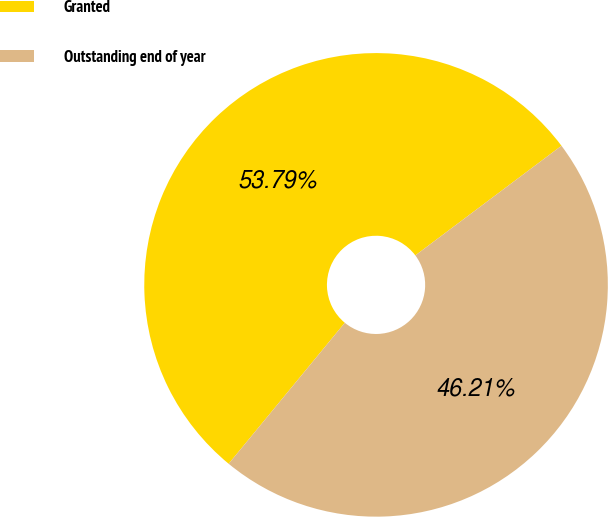<chart> <loc_0><loc_0><loc_500><loc_500><pie_chart><fcel>Granted<fcel>Outstanding end of year<nl><fcel>53.79%<fcel>46.21%<nl></chart> 